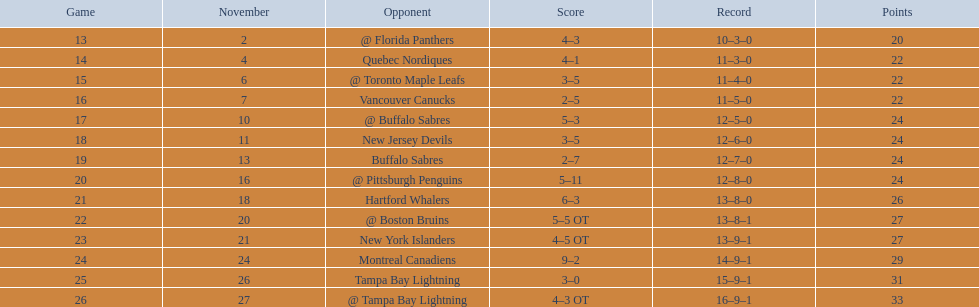Can you give me this table in json format? {'header': ['Game', 'November', 'Opponent', 'Score', 'Record', 'Points'], 'rows': [['13', '2', '@ Florida Panthers', '4–3', '10–3–0', '20'], ['14', '4', 'Quebec Nordiques', '4–1', '11–3–0', '22'], ['15', '6', '@ Toronto Maple Leafs', '3–5', '11–4–0', '22'], ['16', '7', 'Vancouver Canucks', '2–5', '11–5–0', '22'], ['17', '10', '@ Buffalo Sabres', '5–3', '12–5–0', '24'], ['18', '11', 'New Jersey Devils', '3–5', '12–6–0', '24'], ['19', '13', 'Buffalo Sabres', '2–7', '12–7–0', '24'], ['20', '16', '@ Pittsburgh Penguins', '5–11', '12–8–0', '24'], ['21', '18', 'Hartford Whalers', '6–3', '13–8–0', '26'], ['22', '20', '@ Boston Bruins', '5–5 OT', '13–8–1', '27'], ['23', '21', 'New York Islanders', '4–5 OT', '13–9–1', '27'], ['24', '24', 'Montreal Canadiens', '9–2', '14–9–1', '29'], ['25', '26', 'Tampa Bay Lightning', '3–0', '15–9–1', '31'], ['26', '27', '@ Tampa Bay Lightning', '4–3 OT', '16–9–1', '33']]} Can you name all the teams? @ Florida Panthers, Quebec Nordiques, @ Toronto Maple Leafs, Vancouver Canucks, @ Buffalo Sabres, New Jersey Devils, Buffalo Sabres, @ Pittsburgh Penguins, Hartford Whalers, @ Boston Bruins, New York Islanders, Montreal Canadiens, Tampa Bay Lightning. Which contests concluded in overtime? 22, 23, 26. Who was the opponent in game 23? New York Islanders. 